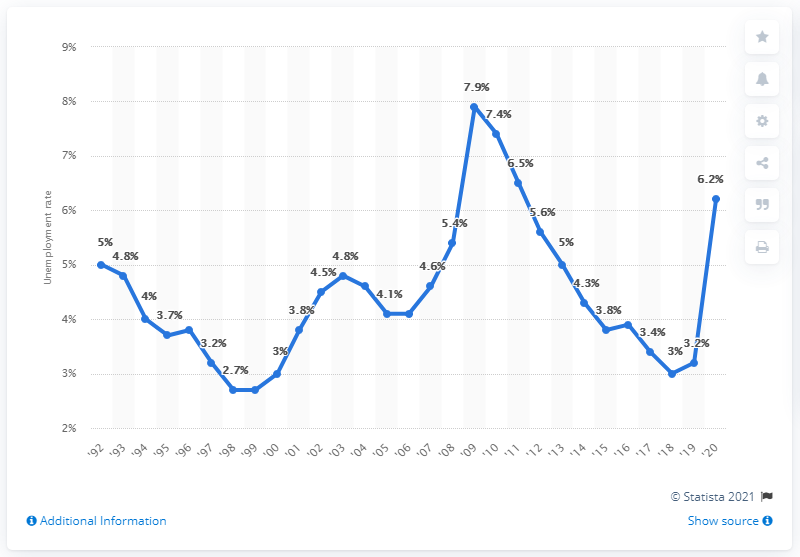Draw attention to some important aspects in this diagram. In 2020, the unemployment rate in Minnesota was 6.2%. 